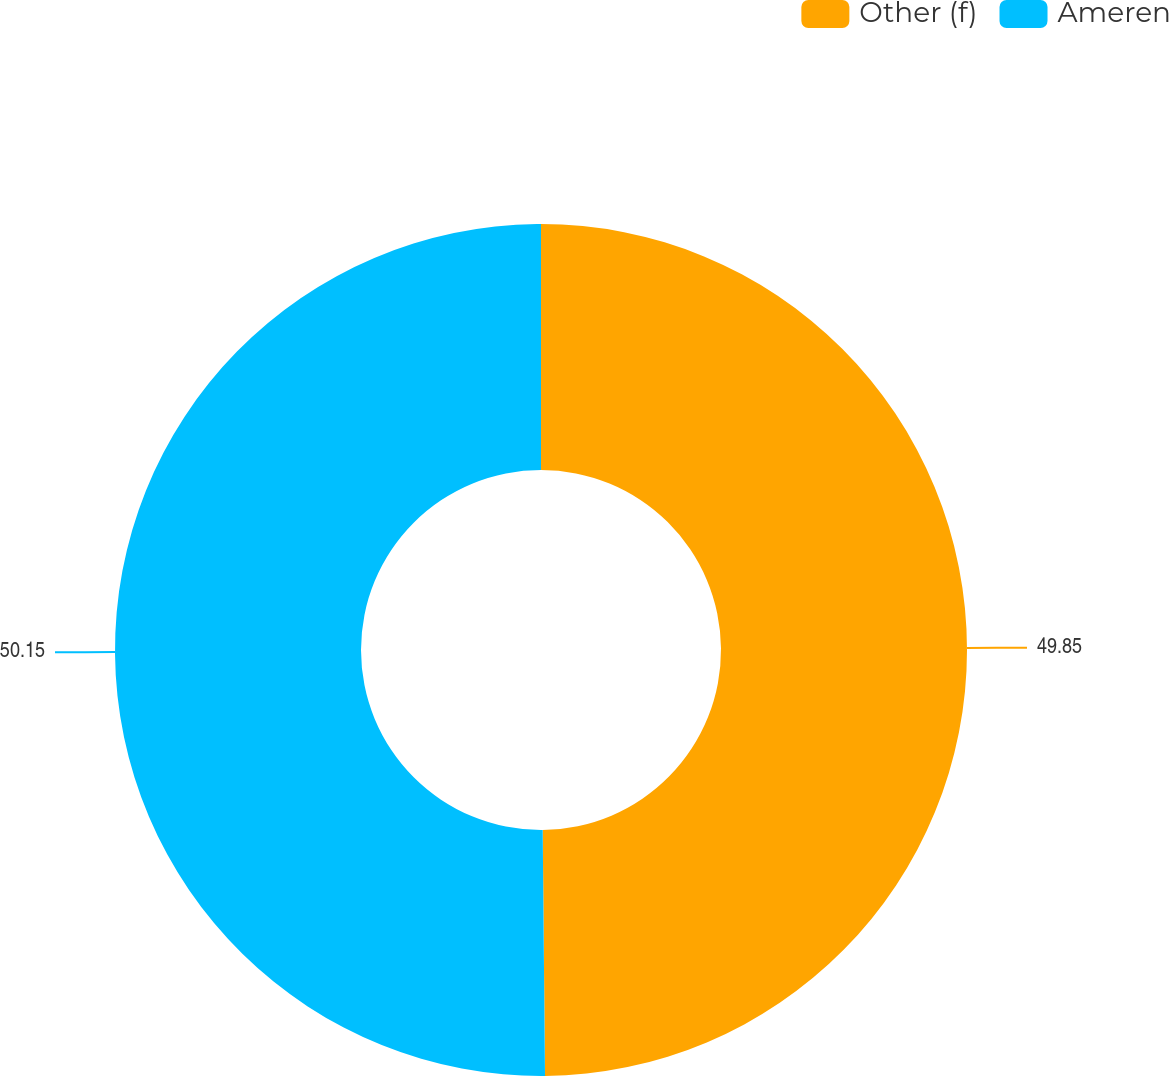Convert chart. <chart><loc_0><loc_0><loc_500><loc_500><pie_chart><fcel>Other (f)<fcel>Ameren<nl><fcel>49.85%<fcel>50.15%<nl></chart> 